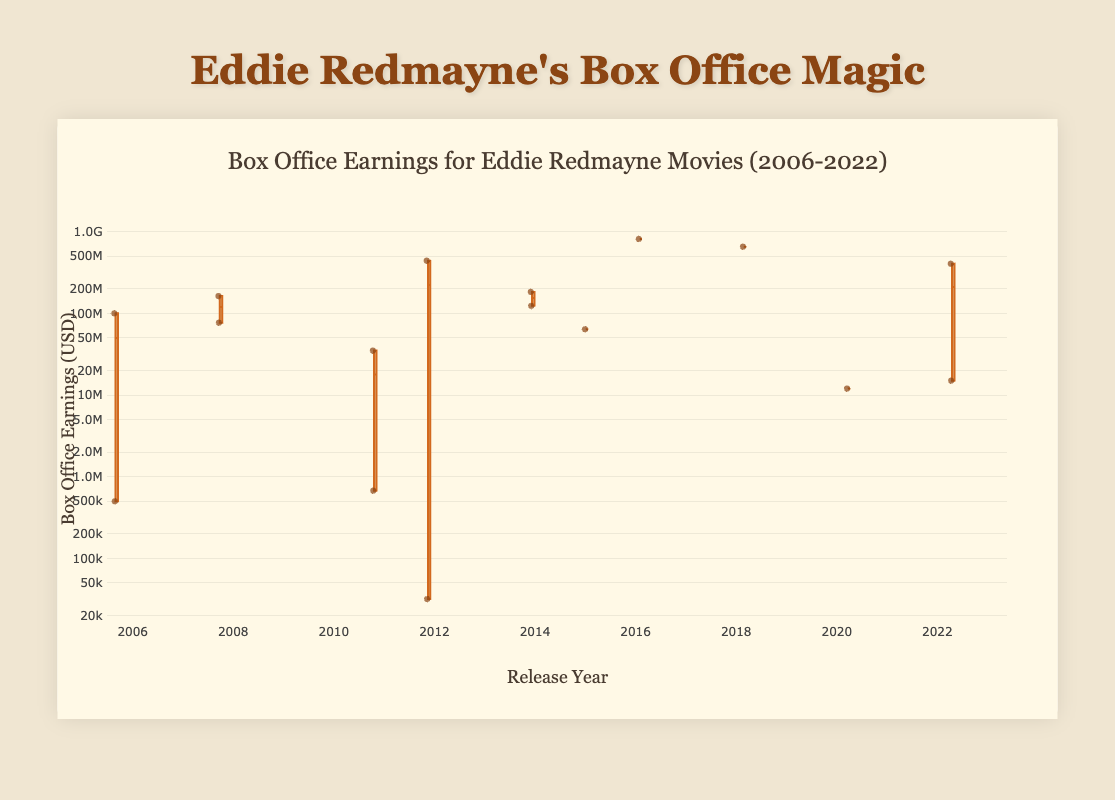What is the title of the box plot? The title is prominently displayed at the top of the box plot, indicating the overall subject of the data being shown.
Answer: Box Office Earnings for Eddie Redmayne Movies (2006-2022) Which release year has the highest median earnings? Look at the middle line within each box for different years, which represents the median. The box with the highest median line denotes the year with the highest median earnings.
Answer: 2016 Can you spot any outliers in the box plot? Outliers are typically represented as individual points lying far from the box and whiskers. Look for these points above or below the main visualization.
Answer: Yes, several outliers are present, such as in 2012 and 2020 What is the interquartile range (IQR) for the earnings in 2012? The IQR is the range between the first quartile (bottom line of the box) and the third quartile (top line of the box). Measure the distance between these two lines on the y-axis for 2012.
Answer: Approximately $40,000,000 to $441,800,000 How does the variability of box office earnings in 2018 compare to 2020? Compare the sizes of the boxes and the lengths of the whiskers for 2018 and 2020. Larger boxes and longer whiskers indicate higher variability.
Answer: The variability in 2018 is much larger than in 2020 Which year shows the greatest range between the minimum and maximum earnings? Identify the year with the longest distance between the bottom whisker and the top whisker, indicating the overall range.
Answer: 2012 Which movie earned the most in 2022? The highest point or line in 2022 denotes the movie with the maximum earnings. Identify this point and refer to the movie title provided in the data.
Answer: Fantastic Beasts: The Secrets of Dumbledore What do the whiskers in each box represent? In a box plot, whiskers typically represent the spread of the data, showing the range from the first quartile minus 1.5*IQR to the third quartile plus 1.5*IQR.
Answer: Spread of the data How does the median earning in 2011 compare to the median earning in 2015? Check the middle line of the boxes for 2011 and 2015 to compare the median values.
Answer: The median earning in 2011 is lower than in 2015 Are there any years with only one data point shown? Years with only one data point will not have a full box plot, just a single point. Identify if there are any such years present in the plot.
Answer: Yes, 2015 and 2016 